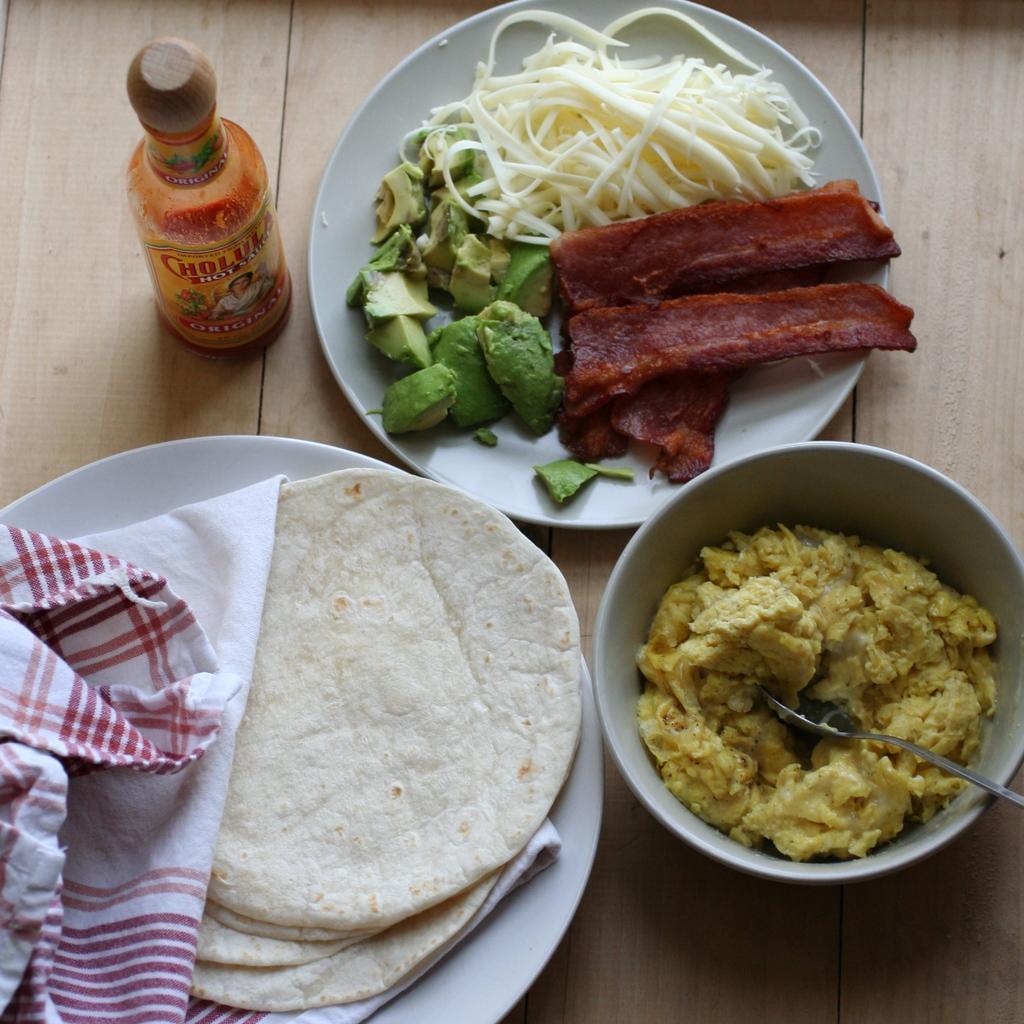Could you give a brief overview of what you see in this image? The picture consists of various food items, plates, bottle, spoon, cloth and a wooden table. 